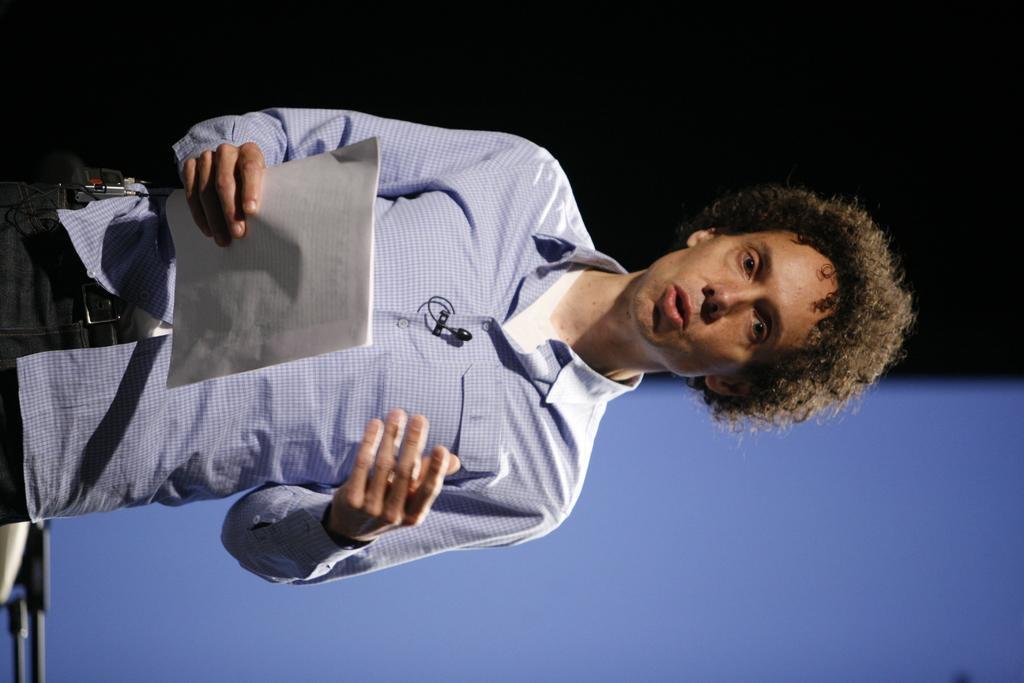Describe this image in one or two sentences. In this image, we can see a man holding papers in his hand. 